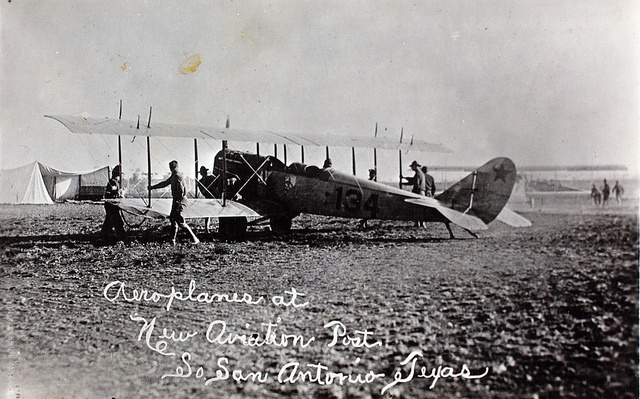Describe the objects in this image and their specific colors. I can see airplane in lightgray, black, gray, and darkgray tones, people in lightgray, black, darkgray, and gray tones, people in lightgray, black, gray, and darkgray tones, people in lightgray, black, gray, and darkgray tones, and people in lightgray, black, gray, and darkgray tones in this image. 